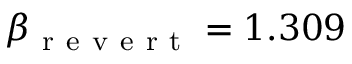<formula> <loc_0><loc_0><loc_500><loc_500>\beta _ { r e v e r t } = 1 . 3 0 9</formula> 